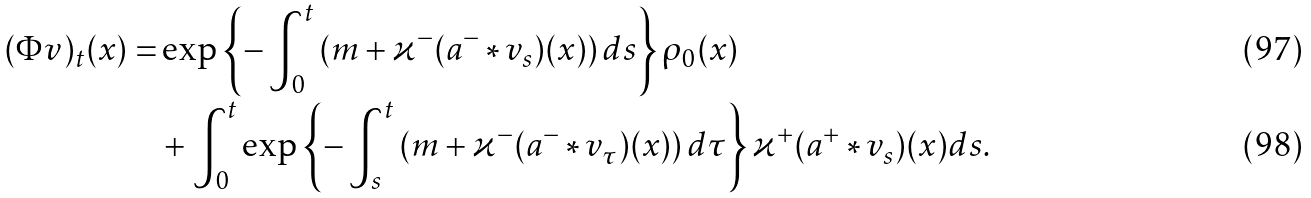Convert formula to latex. <formula><loc_0><loc_0><loc_500><loc_500>( \Phi v ) _ { t } ( x ) = & \exp \left \{ - \int _ { 0 } ^ { t } \left ( m + \varkappa ^ { - } ( a ^ { - } \ast v _ { s } ) ( x ) \right ) d s \right \} \rho _ { 0 } ( x ) \\ & + \int _ { 0 } ^ { t } \exp \left \{ - \int _ { s } ^ { t } \left ( m + \varkappa ^ { - } ( a ^ { - } \ast v _ { \tau } ) ( x ) \right ) d \tau \right \} \varkappa ^ { + } ( a ^ { + } \ast v _ { s } ) ( x ) d s .</formula> 